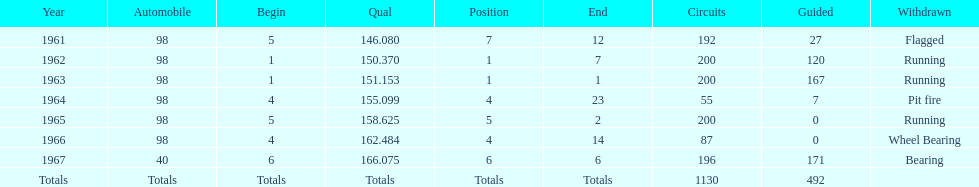How many overall laps have been raced in the indy 500? 1130. 